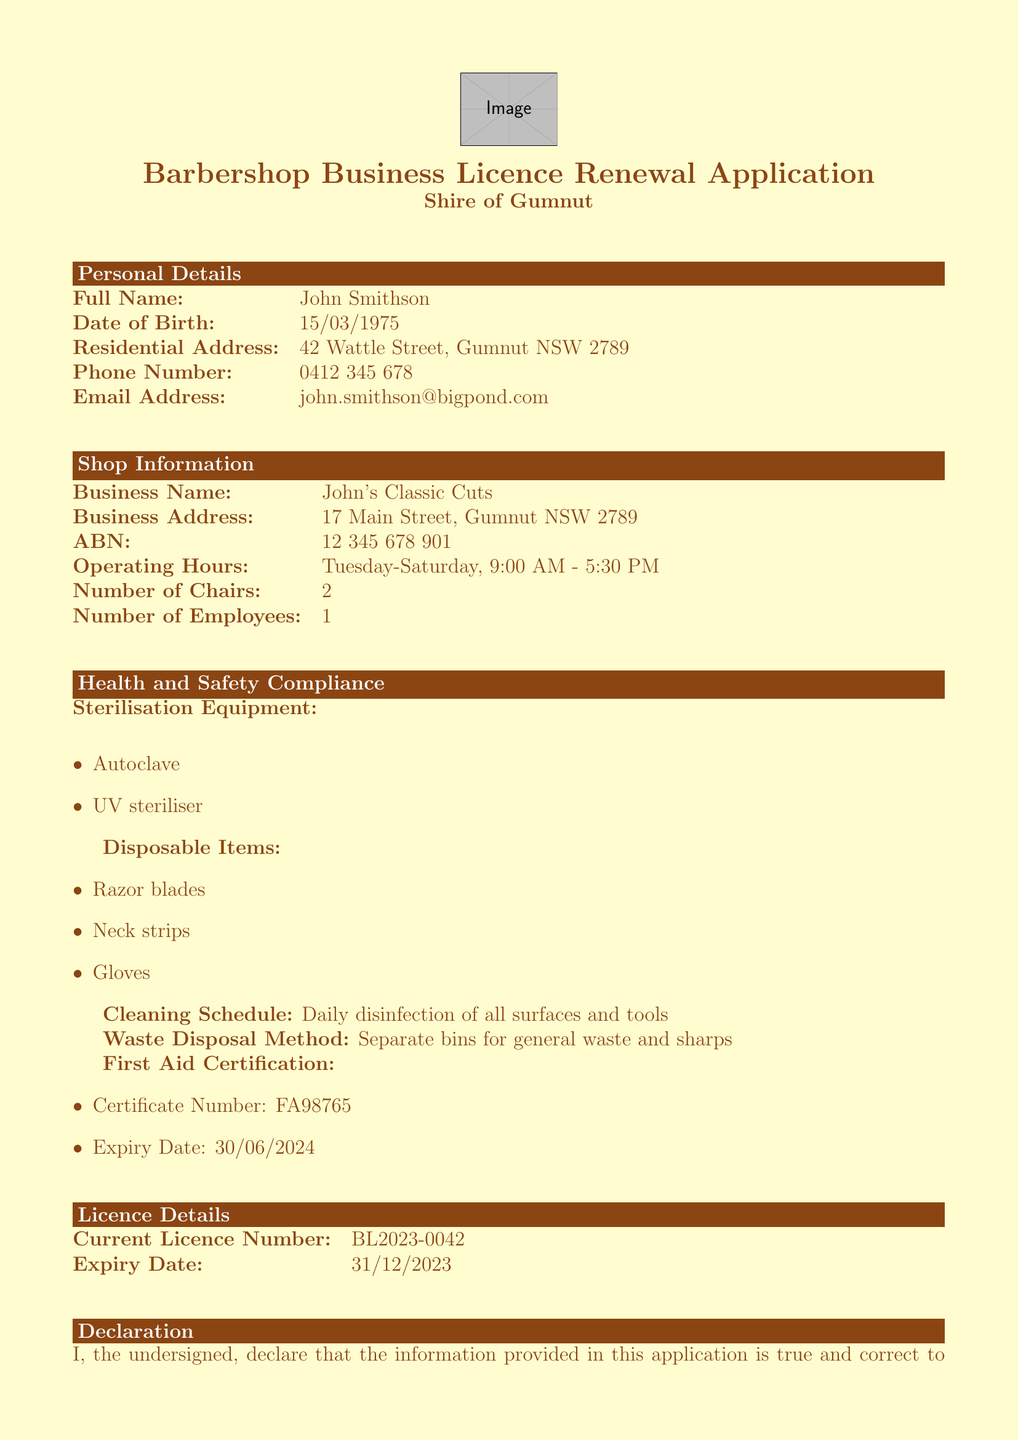what is the full name on the application? The full name is listed in the personal details section of the document.
Answer: John Smithson what is the date of birth provided? The date of birth can be found in the personal details section.
Answer: 15/03/1975 what is the business name of the barbershop? The business name is mentioned in the shop information section.
Answer: John's Classic Cuts how many chairs are at the barbershop? The number of chairs is provided in the shop information section.
Answer: 2 what is the expiry date of the current licence? The expiry date is specified in the licence details section.
Answer: 31/12/2023 what is the waste disposal method mentioned? The waste disposal method can be found under health and safety compliance.
Answer: Separate bins for general waste and sharps what is the first aid certification expiry date? The expiry date for the first aid certification can be found in the health and safety compliance section.
Answer: 30/06/2024 how much is the renewal fee? The renewal fee is indicated in the submission instructions section.
Answer: $150 what payment options are available? The payment options can be found in the payment options section.
Answer: Cash, Cheque, EFTPOS, Bank transfer what must be declared in the application? The declaration section outlines what the applicant must affirm.
Answer: Information provided is true and correct 